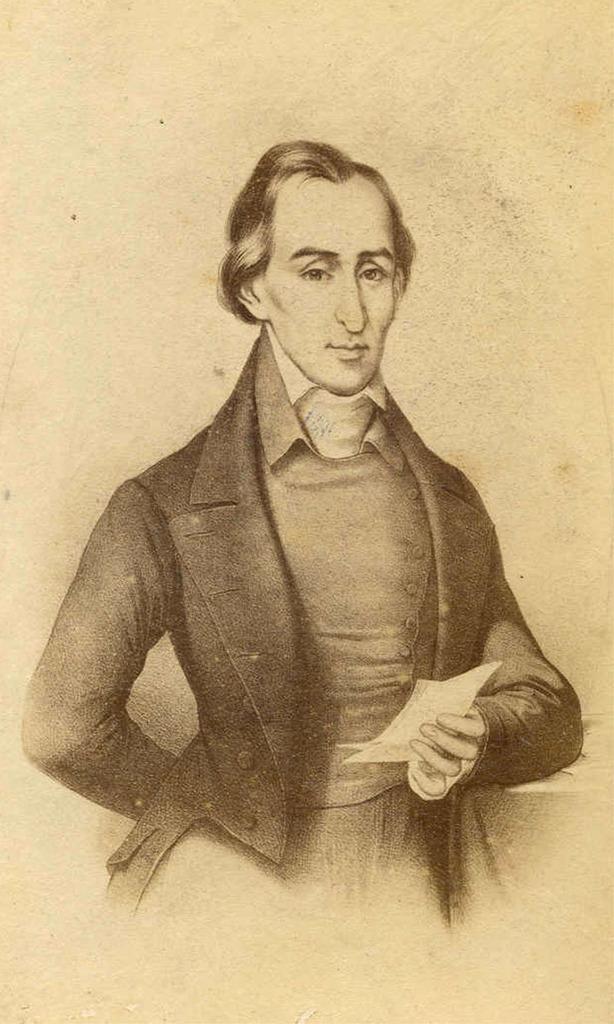Can you describe this image briefly? In this image I can see depiction of a man wearing black coat. I can see he is holding few papers. I can also see little bit cream colour in background. 